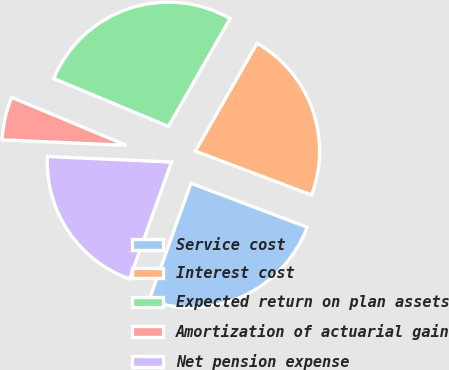Convert chart to OTSL. <chart><loc_0><loc_0><loc_500><loc_500><pie_chart><fcel>Service cost<fcel>Interest cost<fcel>Expected return on plan assets<fcel>Amortization of actuarial gain<fcel>Net pension expense<nl><fcel>24.72%<fcel>22.48%<fcel>26.97%<fcel>5.6%<fcel>20.23%<nl></chart> 